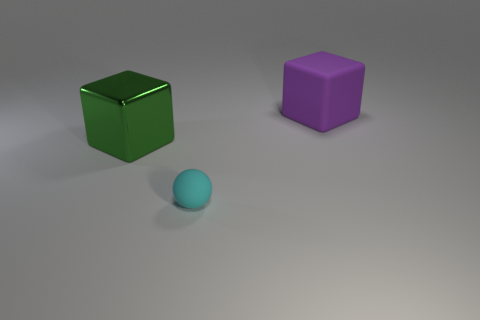Is there any other thing that has the same material as the big green thing?
Your response must be concise. No. Are there more cubes that are to the right of the small cyan matte sphere than cubes to the left of the large green metal object?
Provide a short and direct response. Yes. There is a object that is both right of the large green shiny block and on the left side of the large matte cube; how big is it?
Your answer should be compact. Small. How many purple rubber objects have the same size as the green metallic block?
Keep it short and to the point. 1. There is a large object in front of the rubber block; does it have the same shape as the large purple object?
Your answer should be compact. Yes. Is the number of green objects in front of the large green block less than the number of small cyan matte spheres?
Provide a short and direct response. Yes. Does the big green shiny thing have the same shape as the thing that is right of the tiny cyan thing?
Offer a terse response. Yes. Is there a large purple cube made of the same material as the small cyan sphere?
Your response must be concise. Yes. Is there a shiny object that is left of the big thing right of the ball left of the big purple matte block?
Ensure brevity in your answer.  Yes. How many other things are the same shape as the small matte thing?
Your response must be concise. 0. 